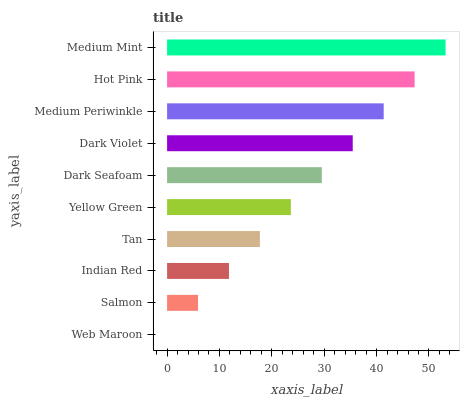Is Web Maroon the minimum?
Answer yes or no. Yes. Is Medium Mint the maximum?
Answer yes or no. Yes. Is Salmon the minimum?
Answer yes or no. No. Is Salmon the maximum?
Answer yes or no. No. Is Salmon greater than Web Maroon?
Answer yes or no. Yes. Is Web Maroon less than Salmon?
Answer yes or no. Yes. Is Web Maroon greater than Salmon?
Answer yes or no. No. Is Salmon less than Web Maroon?
Answer yes or no. No. Is Dark Seafoam the high median?
Answer yes or no. Yes. Is Yellow Green the low median?
Answer yes or no. Yes. Is Yellow Green the high median?
Answer yes or no. No. Is Tan the low median?
Answer yes or no. No. 